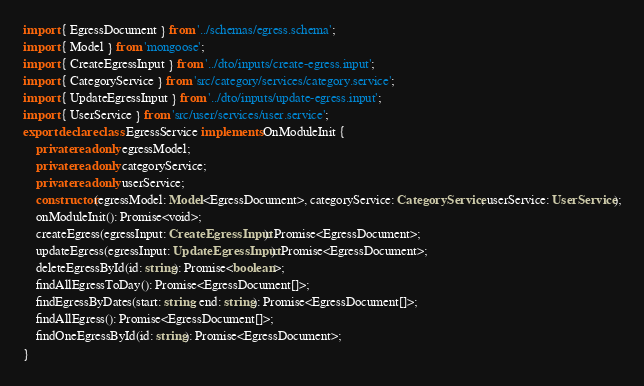<code> <loc_0><loc_0><loc_500><loc_500><_TypeScript_>import { EgressDocument } from '../schemas/egress.schema';
import { Model } from 'mongoose';
import { CreateEgressInput } from '../dto/inputs/create-egress.input';
import { CategoryService } from 'src/category/services/category.service';
import { UpdateEgressInput } from '../dto/inputs/update-egress.input';
import { UserService } from 'src/user/services/user.service';
export declare class EgressService implements OnModuleInit {
    private readonly egressModel;
    private readonly categoryService;
    private readonly userService;
    constructor(egressModel: Model<EgressDocument>, categoryService: CategoryService, userService: UserService);
    onModuleInit(): Promise<void>;
    createEgress(egressInput: CreateEgressInput): Promise<EgressDocument>;
    updateEgress(egressInput: UpdateEgressInput): Promise<EgressDocument>;
    deleteEgressById(id: string): Promise<boolean>;
    findAllEgressToDay(): Promise<EgressDocument[]>;
    findEgressByDates(start: string, end: string): Promise<EgressDocument[]>;
    findAllEgress(): Promise<EgressDocument[]>;
    findOneEgressById(id: string): Promise<EgressDocument>;
}
</code> 